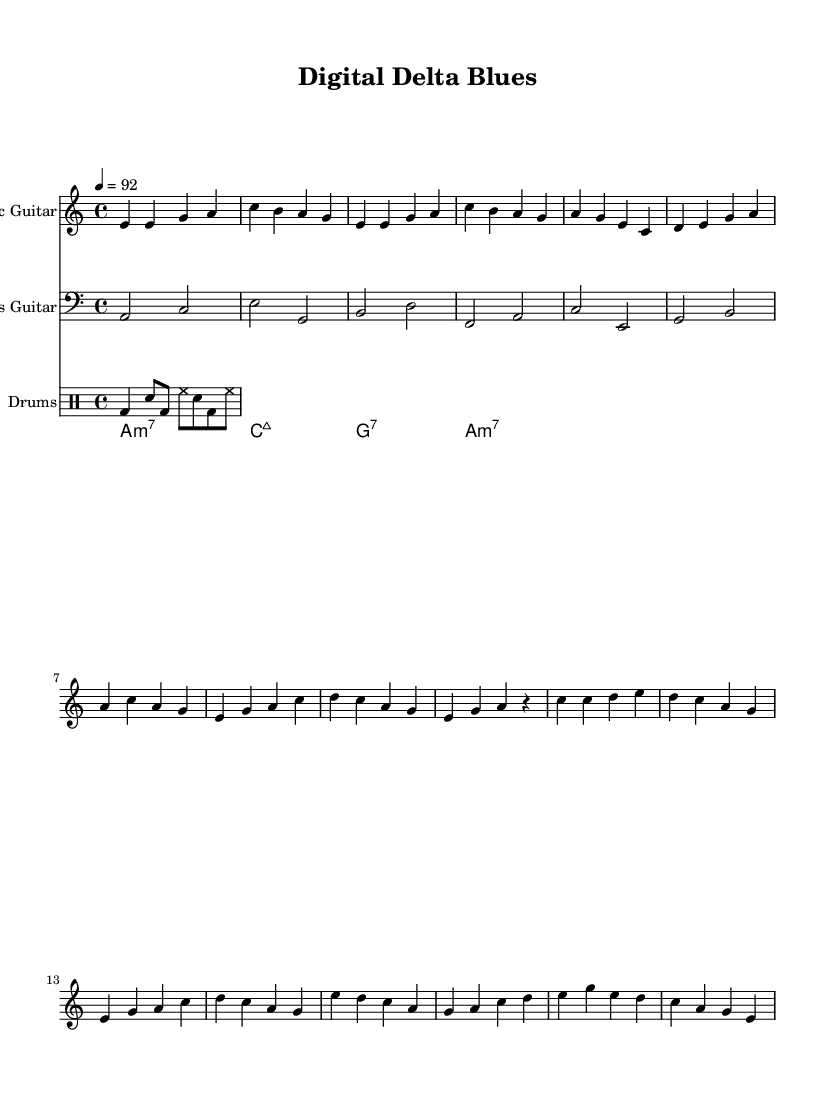What is the key signature of this music? The key signature is indicated at the beginning of the sheet music. It shows one flat (B), which corresponds to the key of A minor.
Answer: A minor What is the time signature of this piece? The time signature is found at the beginning of the score. It is written as "4/4," indicating four beats per measure or bar.
Answer: 4/4 What is the tempo marking provided in the sheet music? The tempo marking specifies the speed of the music. In this piece, it states "4 = 92," which means a quarter note should be played at a speed of 92 beats per minute.
Answer: 92 What is the predominant instrument in this composition? Looking at the instruments listed at the top of each staff, the first staff is labeled "Electric Guitar," indicating it is the primary instrument for this composition.
Answer: Electric Guitar How many measures are in the chorus section? To find the number of measures, I can count the bars in the section labeled "Chorus." There are four measures in the chorus.
Answer: 4 What type of chords are used in the synth pad section? The synth pad section lists the chords with their quality. They are labeled as "m7," "maj7," and "7," indicating minor seventh, major seventh, and dominant seventh chords respectively.
Answer: m7, maj7, 7 What genre does this composition fall under? The title "Digital Delta Blues" and the elements like electric guitar, urban themes, and technology suggest it is of the electric blues genre.
Answer: Electric Blues 